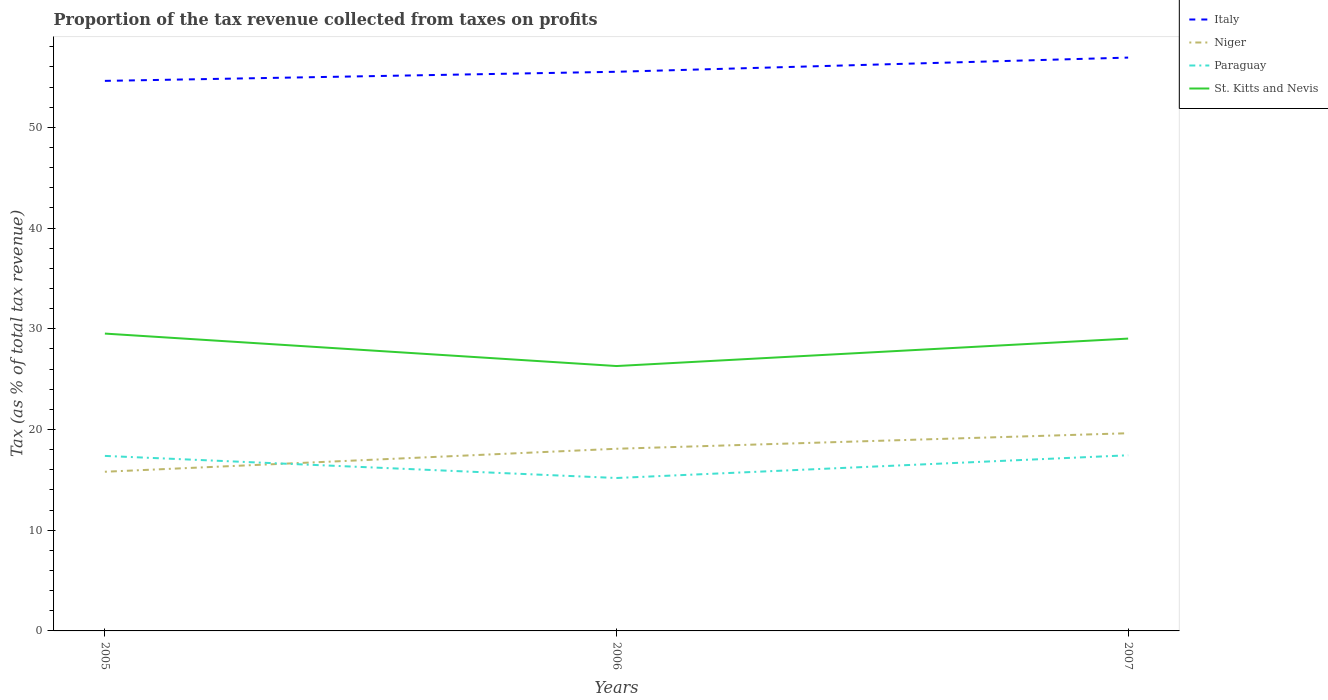How many different coloured lines are there?
Your answer should be compact. 4. Does the line corresponding to Paraguay intersect with the line corresponding to Italy?
Keep it short and to the point. No. Across all years, what is the maximum proportion of the tax revenue collected in Niger?
Provide a short and direct response. 15.81. In which year was the proportion of the tax revenue collected in Italy maximum?
Ensure brevity in your answer.  2005. What is the total proportion of the tax revenue collected in St. Kitts and Nevis in the graph?
Provide a short and direct response. 0.5. What is the difference between the highest and the second highest proportion of the tax revenue collected in Italy?
Provide a short and direct response. 2.31. What is the difference between the highest and the lowest proportion of the tax revenue collected in St. Kitts and Nevis?
Your answer should be very brief. 2. How many years are there in the graph?
Give a very brief answer. 3. What is the difference between two consecutive major ticks on the Y-axis?
Make the answer very short. 10. Does the graph contain grids?
Offer a very short reply. No. How are the legend labels stacked?
Offer a terse response. Vertical. What is the title of the graph?
Provide a short and direct response. Proportion of the tax revenue collected from taxes on profits. Does "Togo" appear as one of the legend labels in the graph?
Keep it short and to the point. No. What is the label or title of the Y-axis?
Provide a succinct answer. Tax (as % of total tax revenue). What is the Tax (as % of total tax revenue) in Italy in 2005?
Your answer should be very brief. 54.62. What is the Tax (as % of total tax revenue) in Niger in 2005?
Offer a terse response. 15.81. What is the Tax (as % of total tax revenue) of Paraguay in 2005?
Your answer should be compact. 17.38. What is the Tax (as % of total tax revenue) of St. Kitts and Nevis in 2005?
Offer a very short reply. 29.53. What is the Tax (as % of total tax revenue) in Italy in 2006?
Give a very brief answer. 55.52. What is the Tax (as % of total tax revenue) of Niger in 2006?
Your answer should be very brief. 18.09. What is the Tax (as % of total tax revenue) of Paraguay in 2006?
Offer a very short reply. 15.19. What is the Tax (as % of total tax revenue) of St. Kitts and Nevis in 2006?
Offer a terse response. 26.3. What is the Tax (as % of total tax revenue) in Italy in 2007?
Give a very brief answer. 56.93. What is the Tax (as % of total tax revenue) in Niger in 2007?
Offer a very short reply. 19.63. What is the Tax (as % of total tax revenue) of Paraguay in 2007?
Give a very brief answer. 17.44. What is the Tax (as % of total tax revenue) of St. Kitts and Nevis in 2007?
Ensure brevity in your answer.  29.03. Across all years, what is the maximum Tax (as % of total tax revenue) in Italy?
Your answer should be very brief. 56.93. Across all years, what is the maximum Tax (as % of total tax revenue) in Niger?
Provide a succinct answer. 19.63. Across all years, what is the maximum Tax (as % of total tax revenue) in Paraguay?
Provide a short and direct response. 17.44. Across all years, what is the maximum Tax (as % of total tax revenue) in St. Kitts and Nevis?
Your answer should be very brief. 29.53. Across all years, what is the minimum Tax (as % of total tax revenue) of Italy?
Your answer should be very brief. 54.62. Across all years, what is the minimum Tax (as % of total tax revenue) in Niger?
Provide a succinct answer. 15.81. Across all years, what is the minimum Tax (as % of total tax revenue) in Paraguay?
Your answer should be very brief. 15.19. Across all years, what is the minimum Tax (as % of total tax revenue) in St. Kitts and Nevis?
Your response must be concise. 26.3. What is the total Tax (as % of total tax revenue) in Italy in the graph?
Offer a very short reply. 167.08. What is the total Tax (as % of total tax revenue) of Niger in the graph?
Your answer should be compact. 53.53. What is the total Tax (as % of total tax revenue) of Paraguay in the graph?
Offer a very short reply. 50.01. What is the total Tax (as % of total tax revenue) in St. Kitts and Nevis in the graph?
Your response must be concise. 84.86. What is the difference between the Tax (as % of total tax revenue) of Italy in 2005 and that in 2006?
Keep it short and to the point. -0.9. What is the difference between the Tax (as % of total tax revenue) in Niger in 2005 and that in 2006?
Offer a terse response. -2.28. What is the difference between the Tax (as % of total tax revenue) of Paraguay in 2005 and that in 2006?
Your answer should be very brief. 2.19. What is the difference between the Tax (as % of total tax revenue) in St. Kitts and Nevis in 2005 and that in 2006?
Provide a short and direct response. 3.22. What is the difference between the Tax (as % of total tax revenue) in Italy in 2005 and that in 2007?
Offer a very short reply. -2.31. What is the difference between the Tax (as % of total tax revenue) in Niger in 2005 and that in 2007?
Offer a terse response. -3.83. What is the difference between the Tax (as % of total tax revenue) of Paraguay in 2005 and that in 2007?
Your response must be concise. -0.06. What is the difference between the Tax (as % of total tax revenue) of St. Kitts and Nevis in 2005 and that in 2007?
Provide a short and direct response. 0.5. What is the difference between the Tax (as % of total tax revenue) of Italy in 2006 and that in 2007?
Provide a succinct answer. -1.41. What is the difference between the Tax (as % of total tax revenue) in Niger in 2006 and that in 2007?
Ensure brevity in your answer.  -1.54. What is the difference between the Tax (as % of total tax revenue) in Paraguay in 2006 and that in 2007?
Your response must be concise. -2.26. What is the difference between the Tax (as % of total tax revenue) of St. Kitts and Nevis in 2006 and that in 2007?
Your answer should be very brief. -2.73. What is the difference between the Tax (as % of total tax revenue) of Italy in 2005 and the Tax (as % of total tax revenue) of Niger in 2006?
Give a very brief answer. 36.53. What is the difference between the Tax (as % of total tax revenue) in Italy in 2005 and the Tax (as % of total tax revenue) in Paraguay in 2006?
Give a very brief answer. 39.43. What is the difference between the Tax (as % of total tax revenue) of Italy in 2005 and the Tax (as % of total tax revenue) of St. Kitts and Nevis in 2006?
Provide a succinct answer. 28.32. What is the difference between the Tax (as % of total tax revenue) of Niger in 2005 and the Tax (as % of total tax revenue) of Paraguay in 2006?
Provide a short and direct response. 0.62. What is the difference between the Tax (as % of total tax revenue) in Niger in 2005 and the Tax (as % of total tax revenue) in St. Kitts and Nevis in 2006?
Make the answer very short. -10.5. What is the difference between the Tax (as % of total tax revenue) in Paraguay in 2005 and the Tax (as % of total tax revenue) in St. Kitts and Nevis in 2006?
Your answer should be very brief. -8.92. What is the difference between the Tax (as % of total tax revenue) of Italy in 2005 and the Tax (as % of total tax revenue) of Niger in 2007?
Give a very brief answer. 34.99. What is the difference between the Tax (as % of total tax revenue) in Italy in 2005 and the Tax (as % of total tax revenue) in Paraguay in 2007?
Give a very brief answer. 37.18. What is the difference between the Tax (as % of total tax revenue) of Italy in 2005 and the Tax (as % of total tax revenue) of St. Kitts and Nevis in 2007?
Give a very brief answer. 25.59. What is the difference between the Tax (as % of total tax revenue) in Niger in 2005 and the Tax (as % of total tax revenue) in Paraguay in 2007?
Provide a short and direct response. -1.64. What is the difference between the Tax (as % of total tax revenue) of Niger in 2005 and the Tax (as % of total tax revenue) of St. Kitts and Nevis in 2007?
Make the answer very short. -13.22. What is the difference between the Tax (as % of total tax revenue) of Paraguay in 2005 and the Tax (as % of total tax revenue) of St. Kitts and Nevis in 2007?
Your response must be concise. -11.65. What is the difference between the Tax (as % of total tax revenue) of Italy in 2006 and the Tax (as % of total tax revenue) of Niger in 2007?
Provide a succinct answer. 35.89. What is the difference between the Tax (as % of total tax revenue) of Italy in 2006 and the Tax (as % of total tax revenue) of Paraguay in 2007?
Offer a terse response. 38.08. What is the difference between the Tax (as % of total tax revenue) in Italy in 2006 and the Tax (as % of total tax revenue) in St. Kitts and Nevis in 2007?
Keep it short and to the point. 26.5. What is the difference between the Tax (as % of total tax revenue) in Niger in 2006 and the Tax (as % of total tax revenue) in Paraguay in 2007?
Offer a terse response. 0.65. What is the difference between the Tax (as % of total tax revenue) in Niger in 2006 and the Tax (as % of total tax revenue) in St. Kitts and Nevis in 2007?
Ensure brevity in your answer.  -10.94. What is the difference between the Tax (as % of total tax revenue) in Paraguay in 2006 and the Tax (as % of total tax revenue) in St. Kitts and Nevis in 2007?
Offer a very short reply. -13.84. What is the average Tax (as % of total tax revenue) in Italy per year?
Your response must be concise. 55.69. What is the average Tax (as % of total tax revenue) of Niger per year?
Offer a terse response. 17.84. What is the average Tax (as % of total tax revenue) of Paraguay per year?
Your answer should be very brief. 16.67. What is the average Tax (as % of total tax revenue) of St. Kitts and Nevis per year?
Ensure brevity in your answer.  28.29. In the year 2005, what is the difference between the Tax (as % of total tax revenue) in Italy and Tax (as % of total tax revenue) in Niger?
Keep it short and to the point. 38.81. In the year 2005, what is the difference between the Tax (as % of total tax revenue) of Italy and Tax (as % of total tax revenue) of Paraguay?
Your response must be concise. 37.24. In the year 2005, what is the difference between the Tax (as % of total tax revenue) in Italy and Tax (as % of total tax revenue) in St. Kitts and Nevis?
Give a very brief answer. 25.09. In the year 2005, what is the difference between the Tax (as % of total tax revenue) of Niger and Tax (as % of total tax revenue) of Paraguay?
Give a very brief answer. -1.57. In the year 2005, what is the difference between the Tax (as % of total tax revenue) of Niger and Tax (as % of total tax revenue) of St. Kitts and Nevis?
Your answer should be compact. -13.72. In the year 2005, what is the difference between the Tax (as % of total tax revenue) of Paraguay and Tax (as % of total tax revenue) of St. Kitts and Nevis?
Your response must be concise. -12.15. In the year 2006, what is the difference between the Tax (as % of total tax revenue) in Italy and Tax (as % of total tax revenue) in Niger?
Provide a short and direct response. 37.44. In the year 2006, what is the difference between the Tax (as % of total tax revenue) of Italy and Tax (as % of total tax revenue) of Paraguay?
Ensure brevity in your answer.  40.34. In the year 2006, what is the difference between the Tax (as % of total tax revenue) of Italy and Tax (as % of total tax revenue) of St. Kitts and Nevis?
Provide a succinct answer. 29.22. In the year 2006, what is the difference between the Tax (as % of total tax revenue) in Niger and Tax (as % of total tax revenue) in Paraguay?
Keep it short and to the point. 2.9. In the year 2006, what is the difference between the Tax (as % of total tax revenue) of Niger and Tax (as % of total tax revenue) of St. Kitts and Nevis?
Your answer should be compact. -8.21. In the year 2006, what is the difference between the Tax (as % of total tax revenue) of Paraguay and Tax (as % of total tax revenue) of St. Kitts and Nevis?
Provide a short and direct response. -11.12. In the year 2007, what is the difference between the Tax (as % of total tax revenue) in Italy and Tax (as % of total tax revenue) in Niger?
Your answer should be very brief. 37.3. In the year 2007, what is the difference between the Tax (as % of total tax revenue) of Italy and Tax (as % of total tax revenue) of Paraguay?
Offer a very short reply. 39.49. In the year 2007, what is the difference between the Tax (as % of total tax revenue) in Italy and Tax (as % of total tax revenue) in St. Kitts and Nevis?
Ensure brevity in your answer.  27.9. In the year 2007, what is the difference between the Tax (as % of total tax revenue) in Niger and Tax (as % of total tax revenue) in Paraguay?
Give a very brief answer. 2.19. In the year 2007, what is the difference between the Tax (as % of total tax revenue) of Niger and Tax (as % of total tax revenue) of St. Kitts and Nevis?
Ensure brevity in your answer.  -9.4. In the year 2007, what is the difference between the Tax (as % of total tax revenue) of Paraguay and Tax (as % of total tax revenue) of St. Kitts and Nevis?
Your response must be concise. -11.59. What is the ratio of the Tax (as % of total tax revenue) of Italy in 2005 to that in 2006?
Your response must be concise. 0.98. What is the ratio of the Tax (as % of total tax revenue) of Niger in 2005 to that in 2006?
Your answer should be very brief. 0.87. What is the ratio of the Tax (as % of total tax revenue) in Paraguay in 2005 to that in 2006?
Make the answer very short. 1.14. What is the ratio of the Tax (as % of total tax revenue) of St. Kitts and Nevis in 2005 to that in 2006?
Provide a short and direct response. 1.12. What is the ratio of the Tax (as % of total tax revenue) in Italy in 2005 to that in 2007?
Your answer should be compact. 0.96. What is the ratio of the Tax (as % of total tax revenue) of Niger in 2005 to that in 2007?
Give a very brief answer. 0.81. What is the ratio of the Tax (as % of total tax revenue) of Paraguay in 2005 to that in 2007?
Your answer should be very brief. 1. What is the ratio of the Tax (as % of total tax revenue) in St. Kitts and Nevis in 2005 to that in 2007?
Provide a succinct answer. 1.02. What is the ratio of the Tax (as % of total tax revenue) in Italy in 2006 to that in 2007?
Provide a short and direct response. 0.98. What is the ratio of the Tax (as % of total tax revenue) of Niger in 2006 to that in 2007?
Offer a terse response. 0.92. What is the ratio of the Tax (as % of total tax revenue) in Paraguay in 2006 to that in 2007?
Ensure brevity in your answer.  0.87. What is the ratio of the Tax (as % of total tax revenue) of St. Kitts and Nevis in 2006 to that in 2007?
Offer a terse response. 0.91. What is the difference between the highest and the second highest Tax (as % of total tax revenue) in Italy?
Offer a very short reply. 1.41. What is the difference between the highest and the second highest Tax (as % of total tax revenue) in Niger?
Give a very brief answer. 1.54. What is the difference between the highest and the second highest Tax (as % of total tax revenue) in Paraguay?
Your answer should be very brief. 0.06. What is the difference between the highest and the second highest Tax (as % of total tax revenue) of St. Kitts and Nevis?
Provide a succinct answer. 0.5. What is the difference between the highest and the lowest Tax (as % of total tax revenue) of Italy?
Provide a succinct answer. 2.31. What is the difference between the highest and the lowest Tax (as % of total tax revenue) of Niger?
Provide a short and direct response. 3.83. What is the difference between the highest and the lowest Tax (as % of total tax revenue) in Paraguay?
Give a very brief answer. 2.26. What is the difference between the highest and the lowest Tax (as % of total tax revenue) of St. Kitts and Nevis?
Keep it short and to the point. 3.22. 